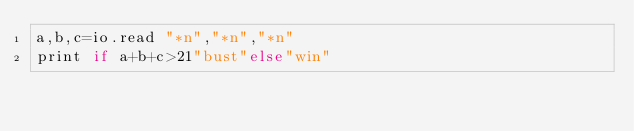<code> <loc_0><loc_0><loc_500><loc_500><_MoonScript_>a,b,c=io.read "*n","*n","*n"
print if a+b+c>21"bust"else"win"</code> 